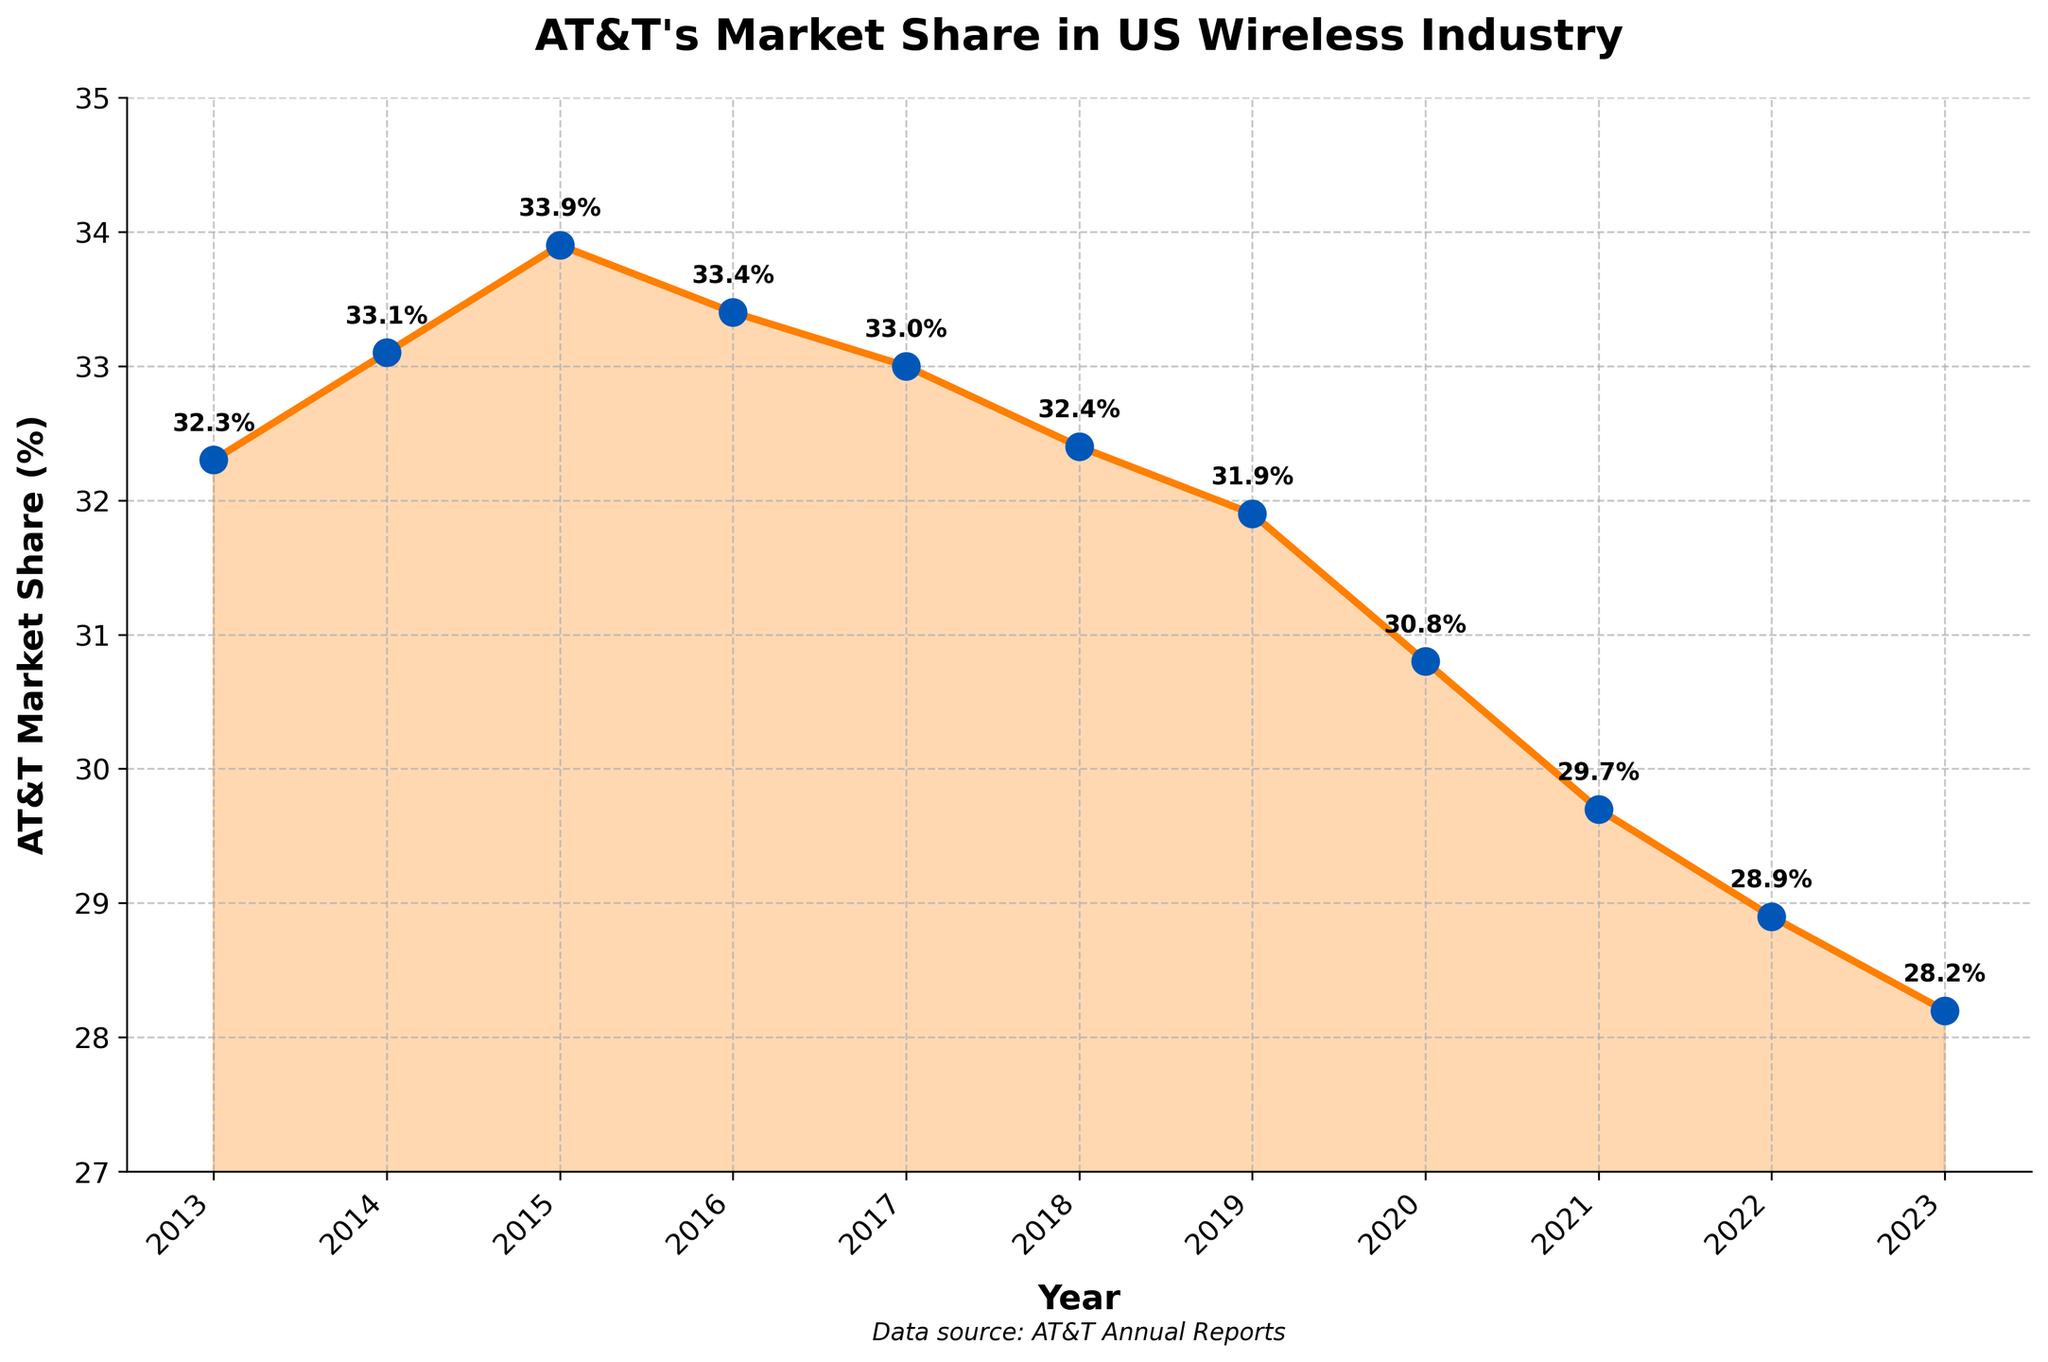How has AT&T's market share changed from 2013 to 2023? To determine the change in AT&T's market share, subtract the market share in 2023 (28.2%) from the market share in 2013 (32.3%). The change is 32.3% - 28.2% = 4.1%.
Answer: It decreased by 4.1% Which year had the highest market share for AT&T and what was it? By examining the data points on the plot, 2015 had the highest market share, which was 33.9%.
Answer: 2015 with 33.9% Is there any year where AT&T's market share increased compared to the previous year? Compare each year's market share with the previous year's. AT&T's market share increased in 2014 (33.1%) from 2013 (32.3%) and in 2015 (33.9%) from 2014 (33.1%).
Answer: Yes, in 2014 and 2015 What is the overall trend in AT&T's market share from 2013 to 2023? By observing the pattern of the line chart, there is an increasing trend until 2015 followed by a generally decreasing trend from 2016 onwards.
Answer: Initial increase, then decrease In which year did AT&T's market share first drop below 30%? Find the first year where the market share is less than 30%. This occurred in 2021 with a market share of 29.7%.
Answer: 2021 What is the average market share of AT&T from 2013 to 2023? Sum all market share values and divide by the number of years: (32.3 + 33.1 + 33.9 + 33.4 + 33.0 + 32.4 + 31.9 + 30.8 + 29.7 + 28.9 + 28.2) / 11 = 31.8
Answer: 31.8% Compare market share trends between 2015 and 2023. Did AT&T primarily gain or lose market share? Identify the trends from 2015 (highest point at 33.9%) to 2023 (28.2%). The trend shows a consistent loss in market share through the period.
Answer: Primarily lost Which year experienced the largest single-year drop in market share, and what was the magnitude of this drop? Review year-to-year changes and find the maximum drop in percentage. The largest drop was from 2019 (31.9%) to 2020 (30.8%), a 1.1% decrease.
Answer: 2019 to 2020, 1.1% What is the median market share over the decade? Order the market share values and find the median (middle) value: 28.2, 28.9, 29.7, 30.8, 31.9, 32.3, 32.4, 33.0, 33.1, 33.4, 33.9. The middle value (median) is 32.3%.
Answer: 32.3% Visually, which part of the graph shows the most consistent market share, and what years does it span? By examining the stability of the line, the market share appears most consistent from 2013-2017 where the values hover around 32.3% to 33.4%.
Answer: 2013-2017 